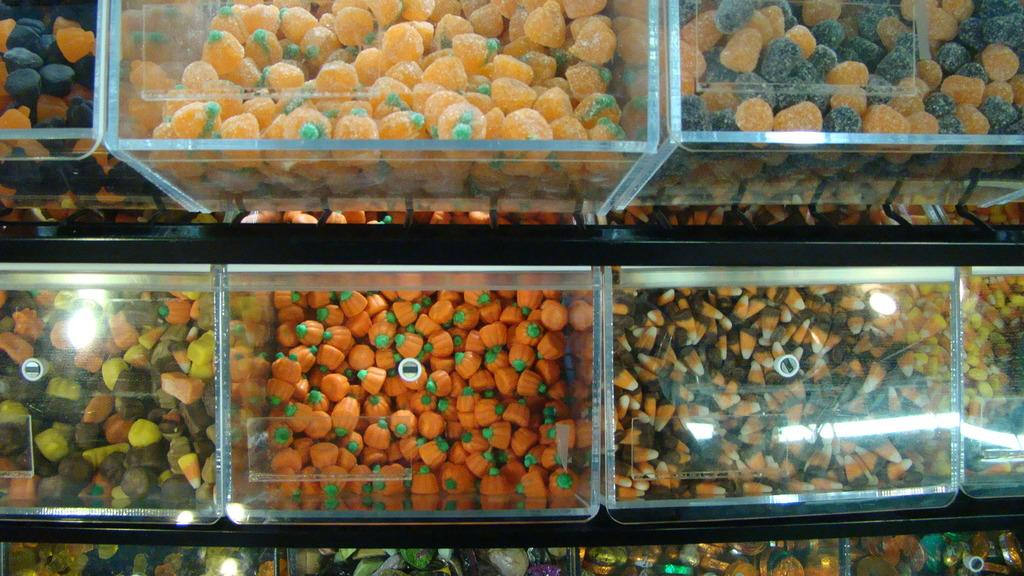What type of items can be seen in the image? There are food items in the image. How are the food items stored or organized? The food items are in boxes. Where are the boxes with food items placed? The boxes are placed on racks. What type of border is depicted in the image? There is no border present in the image; it features food items in boxes placed on racks. What type of trade is being conducted in the image? There is no trade being conducted in the image; it features food items in boxes placed on racks. 